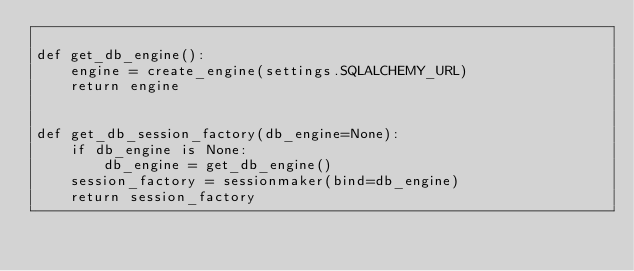<code> <loc_0><loc_0><loc_500><loc_500><_Python_>
def get_db_engine():
    engine = create_engine(settings.SQLALCHEMY_URL)
    return engine


def get_db_session_factory(db_engine=None):
    if db_engine is None:
        db_engine = get_db_engine()
    session_factory = sessionmaker(bind=db_engine)
    return session_factory
</code> 